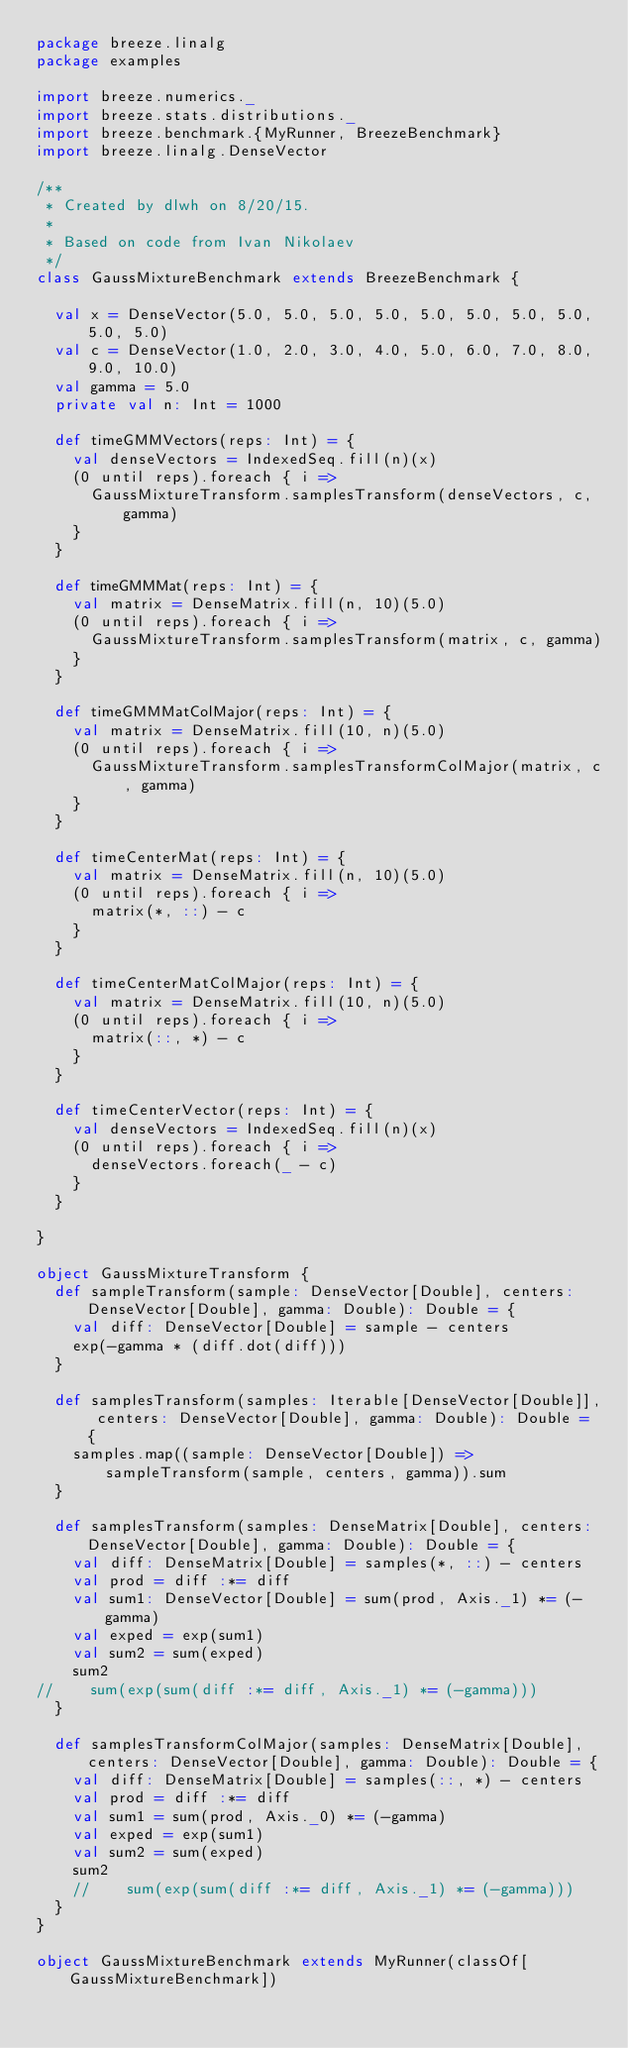Convert code to text. <code><loc_0><loc_0><loc_500><loc_500><_Scala_>package breeze.linalg
package examples

import breeze.numerics._
import breeze.stats.distributions._
import breeze.benchmark.{MyRunner, BreezeBenchmark}
import breeze.linalg.DenseVector

/**
 * Created by dlwh on 8/20/15.
 *
 * Based on code from Ivan Nikolaev
 */
class GaussMixtureBenchmark extends BreezeBenchmark {

  val x = DenseVector(5.0, 5.0, 5.0, 5.0, 5.0, 5.0, 5.0, 5.0, 5.0, 5.0)
  val c = DenseVector(1.0, 2.0, 3.0, 4.0, 5.0, 6.0, 7.0, 8.0, 9.0, 10.0)
  val gamma = 5.0
  private val n: Int = 1000

  def timeGMMVectors(reps: Int) = {
    val denseVectors = IndexedSeq.fill(n)(x)
    (0 until reps).foreach { i =>
      GaussMixtureTransform.samplesTransform(denseVectors, c, gamma)
    }
  }

  def timeGMMMat(reps: Int) = {
    val matrix = DenseMatrix.fill(n, 10)(5.0)
    (0 until reps).foreach { i =>
      GaussMixtureTransform.samplesTransform(matrix, c, gamma)
    }
  }

  def timeGMMMatColMajor(reps: Int) = {
    val matrix = DenseMatrix.fill(10, n)(5.0)
    (0 until reps).foreach { i =>
      GaussMixtureTransform.samplesTransformColMajor(matrix, c, gamma)
    }
  }

  def timeCenterMat(reps: Int) = {
    val matrix = DenseMatrix.fill(n, 10)(5.0)
    (0 until reps).foreach { i =>
      matrix(*, ::) - c
    }
  }

  def timeCenterMatColMajor(reps: Int) = {
    val matrix = DenseMatrix.fill(10, n)(5.0)
    (0 until reps).foreach { i =>
      matrix(::, *) - c
    }
  }

  def timeCenterVector(reps: Int) = {
    val denseVectors = IndexedSeq.fill(n)(x)
    (0 until reps).foreach { i =>
      denseVectors.foreach(_ - c)
    }
  }

}

object GaussMixtureTransform {
  def sampleTransform(sample: DenseVector[Double], centers: DenseVector[Double], gamma: Double): Double = {
    val diff: DenseVector[Double] = sample - centers
    exp(-gamma * (diff.dot(diff)))
  }

  def samplesTransform(samples: Iterable[DenseVector[Double]], centers: DenseVector[Double], gamma: Double): Double = {
    samples.map((sample: DenseVector[Double]) => sampleTransform(sample, centers, gamma)).sum
  }

  def samplesTransform(samples: DenseMatrix[Double], centers: DenseVector[Double], gamma: Double): Double = {
    val diff: DenseMatrix[Double] = samples(*, ::) - centers
    val prod = diff :*= diff
    val sum1: DenseVector[Double] = sum(prod, Axis._1) *= (-gamma)
    val exped = exp(sum1)
    val sum2 = sum(exped)
    sum2
//    sum(exp(sum(diff :*= diff, Axis._1) *= (-gamma)))
  }

  def samplesTransformColMajor(samples: DenseMatrix[Double], centers: DenseVector[Double], gamma: Double): Double = {
    val diff: DenseMatrix[Double] = samples(::, *) - centers
    val prod = diff :*= diff
    val sum1 = sum(prod, Axis._0) *= (-gamma)
    val exped = exp(sum1)
    val sum2 = sum(exped)
    sum2
    //    sum(exp(sum(diff :*= diff, Axis._1) *= (-gamma)))
  }
}

object GaussMixtureBenchmark extends MyRunner(classOf[GaussMixtureBenchmark])
</code> 